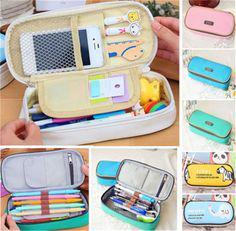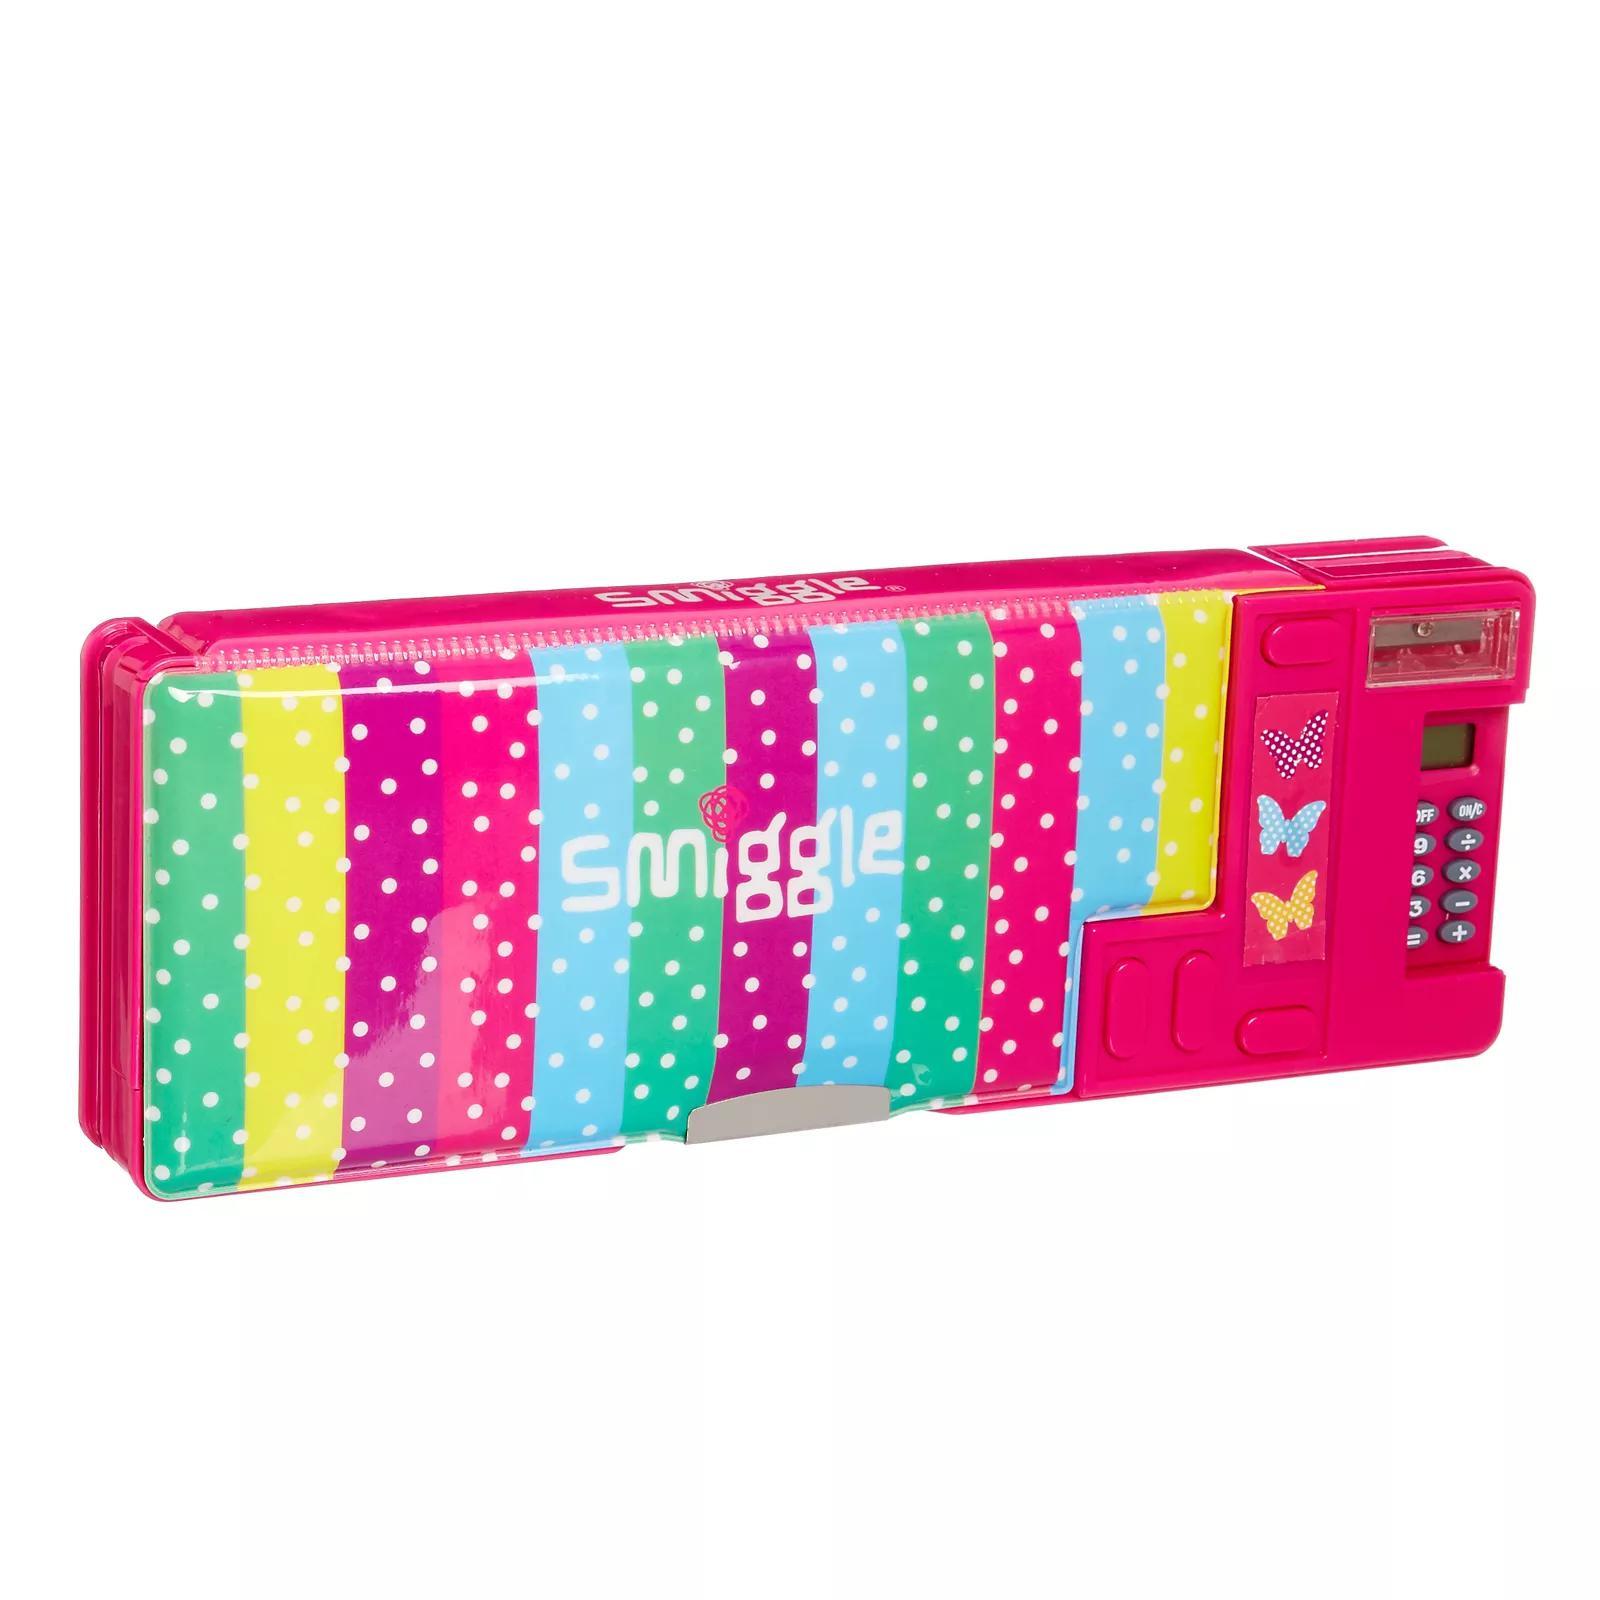The first image is the image on the left, the second image is the image on the right. Examine the images to the left and right. Is the description "A hand is opening a pencil case in the right image." accurate? Answer yes or no. No. 